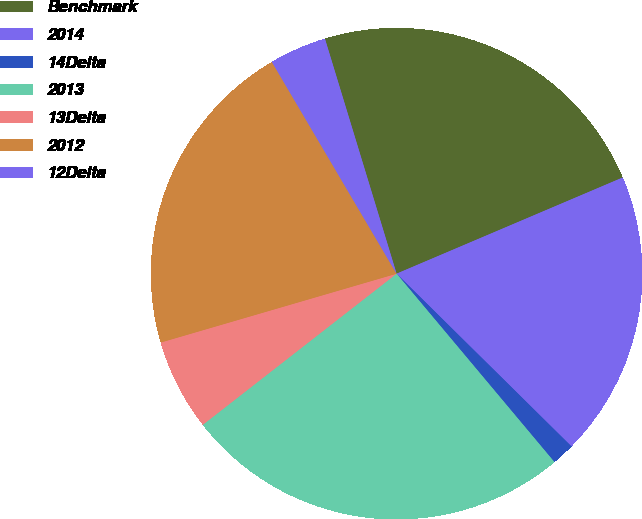Convert chart. <chart><loc_0><loc_0><loc_500><loc_500><pie_chart><fcel>Benchmark<fcel>2014<fcel>14Delta<fcel>2013<fcel>13Delta<fcel>2012<fcel>12Delta<nl><fcel>23.31%<fcel>18.8%<fcel>1.5%<fcel>25.56%<fcel>6.02%<fcel>21.05%<fcel>3.76%<nl></chart> 